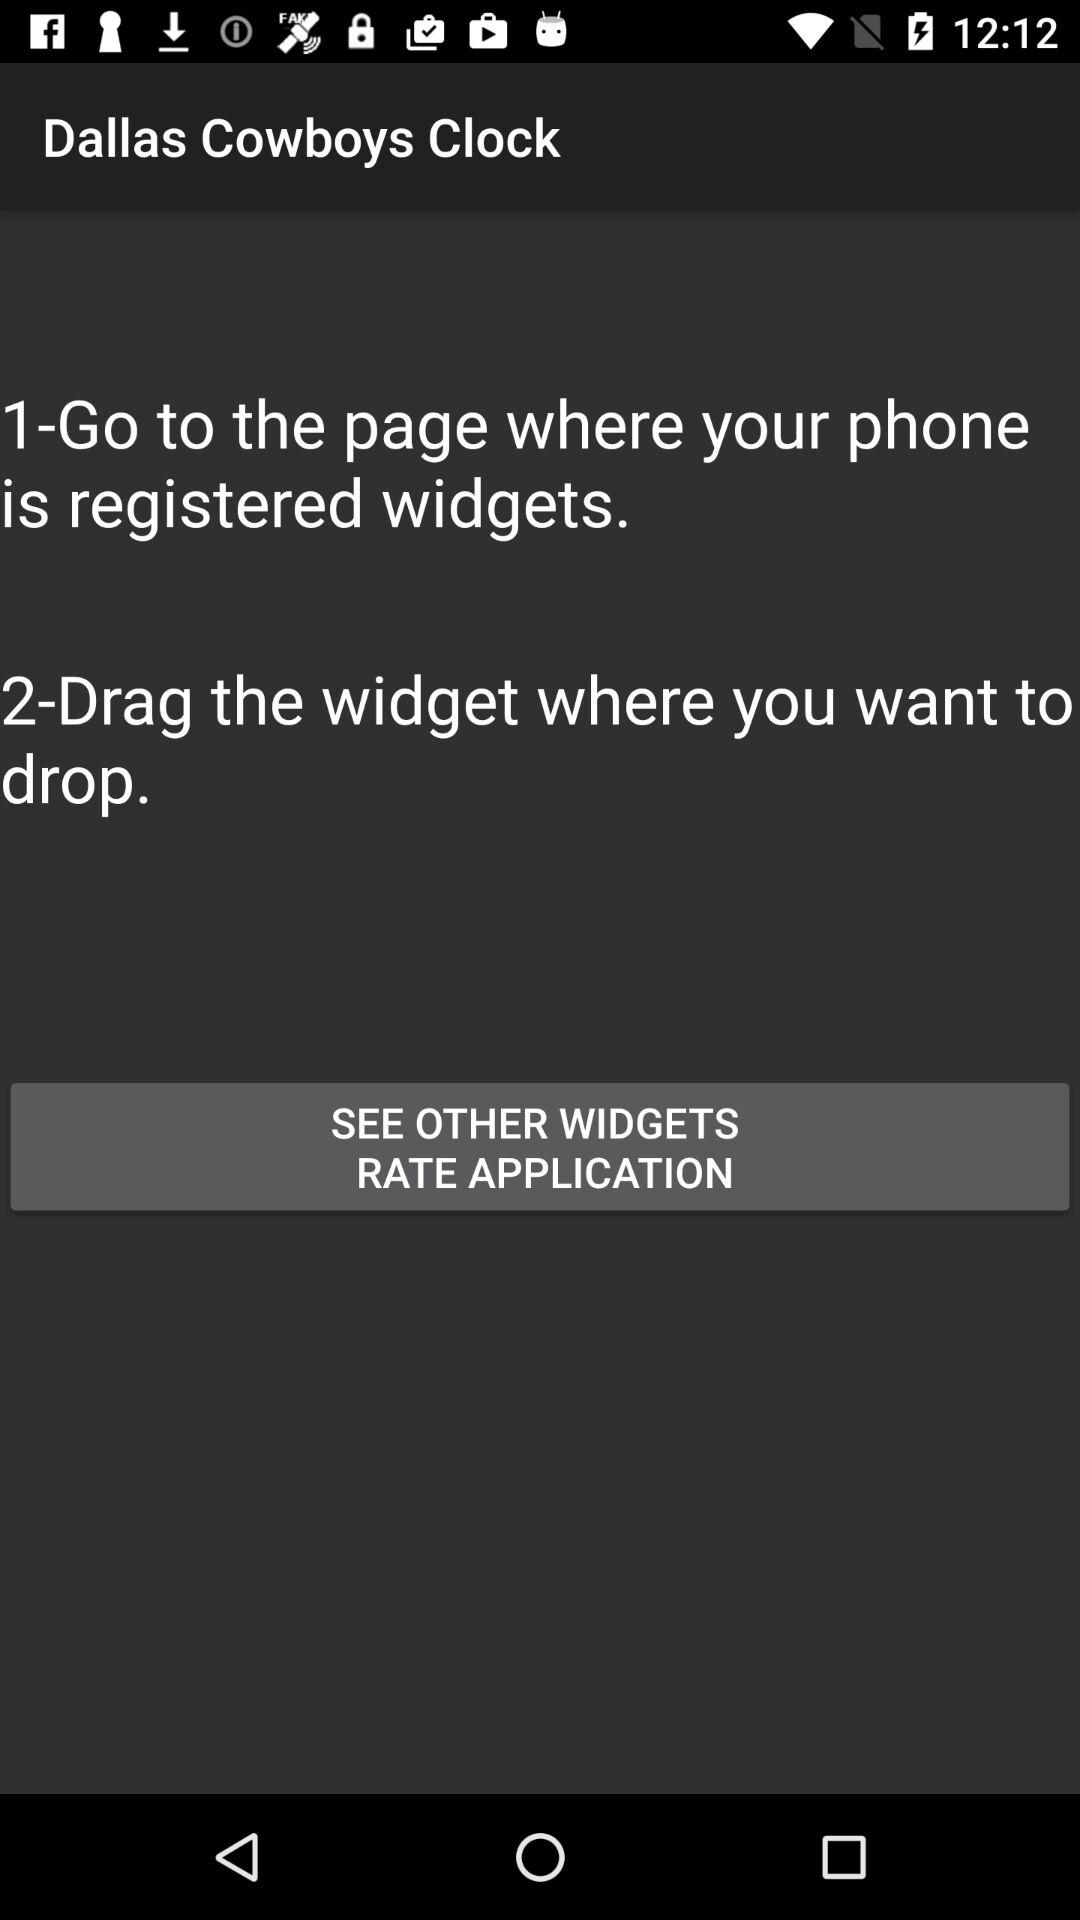What is the name of the application? The name of the application is "Dallas Cowboys Clock". 